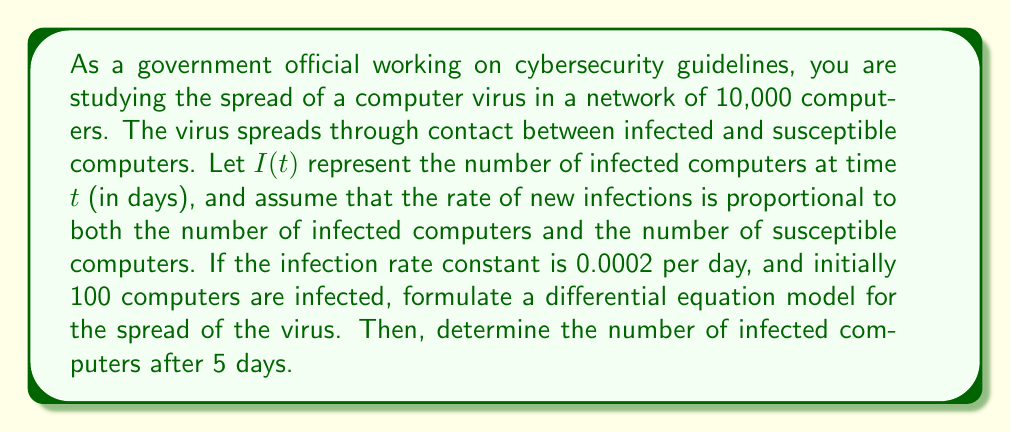Show me your answer to this math problem. Let's approach this problem step by step:

1) First, we need to formulate the differential equation. In this SIS (Susceptible-Infected-Susceptible) model:

   - Total population: $N = 10,000$
   - Infected population: $I(t)$
   - Susceptible population: $S(t) = N - I(t) = 10,000 - I(t)$
   - Infection rate constant: $r = 0.0002$ per day

2) The rate of change of infected computers is proportional to both $I(t)$ and $S(t)$:

   $$\frac{dI}{dt} = rI(t)(N-I(t)) = 0.0002I(t)(10000-I(t))$$

3) This is a logistic differential equation. The solution is:

   $$I(t) = \frac{N}{1 + (\frac{N}{I_0} - 1)e^{-rNt}}$$

   where $I_0$ is the initial number of infected computers.

4) We're given that $I_0 = 100$, $N = 10000$, $r = 0.0002$, and we need to find $I(5)$.

5) Plugging in these values:

   $$I(5) = \frac{10000}{1 + (\frac{10000}{100} - 1)e^{-0.0002 \cdot 10000 \cdot 5}}$$

6) Simplifying:

   $$I(5) = \frac{10000}{1 + 99e^{-10}}$$

7) Using a calculator to evaluate this expression:

   $$I(5) \approx 164.87$$

8) Since we're dealing with whole computers, we round to the nearest integer:

   $$I(5) \approx 165$$
Answer: After 5 days, approximately 165 computers will be infected. 